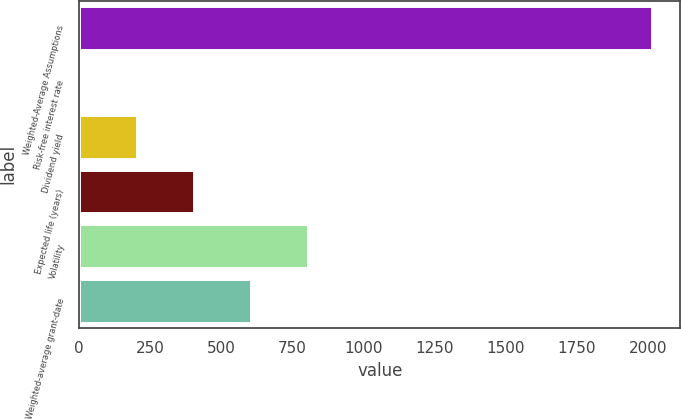Convert chart to OTSL. <chart><loc_0><loc_0><loc_500><loc_500><bar_chart><fcel>Weighted-Average Assumptions<fcel>Risk-free interest rate<fcel>Dividend yield<fcel>Expected life (years)<fcel>Volatility<fcel>Weighted-average grant-date<nl><fcel>2013<fcel>0.8<fcel>202.02<fcel>403.24<fcel>805.68<fcel>604.46<nl></chart> 